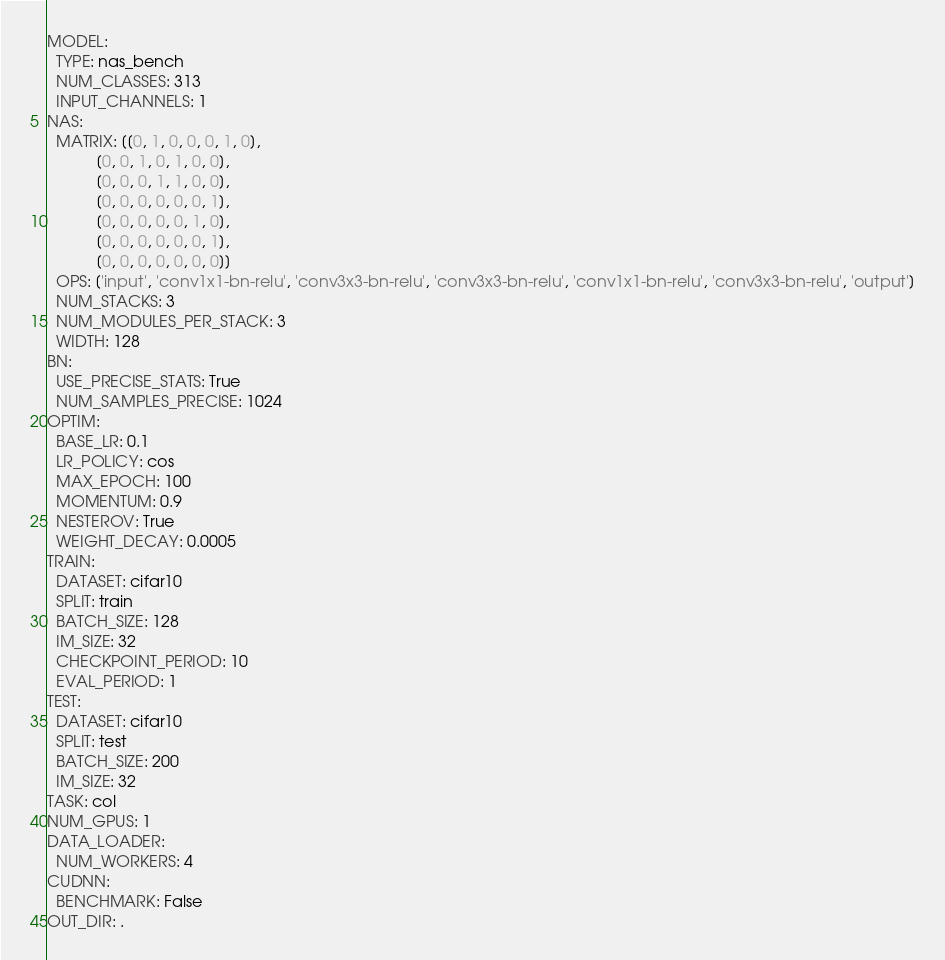Convert code to text. <code><loc_0><loc_0><loc_500><loc_500><_YAML_>MODEL:
  TYPE: nas_bench
  NUM_CLASSES: 313
  INPUT_CHANNELS: 1
NAS:
  MATRIX: [[0, 1, 0, 0, 0, 1, 0],
           [0, 0, 1, 0, 1, 0, 0],
           [0, 0, 0, 1, 1, 0, 0],
           [0, 0, 0, 0, 0, 0, 1],
           [0, 0, 0, 0, 0, 1, 0],
           [0, 0, 0, 0, 0, 0, 1],
           [0, 0, 0, 0, 0, 0, 0]]
  OPS: ['input', 'conv1x1-bn-relu', 'conv3x3-bn-relu', 'conv3x3-bn-relu', 'conv1x1-bn-relu', 'conv3x3-bn-relu', 'output']
  NUM_STACKS: 3
  NUM_MODULES_PER_STACK: 3
  WIDTH: 128
BN:
  USE_PRECISE_STATS: True
  NUM_SAMPLES_PRECISE: 1024
OPTIM:
  BASE_LR: 0.1
  LR_POLICY: cos
  MAX_EPOCH: 100
  MOMENTUM: 0.9
  NESTEROV: True
  WEIGHT_DECAY: 0.0005
TRAIN:
  DATASET: cifar10
  SPLIT: train
  BATCH_SIZE: 128
  IM_SIZE: 32
  CHECKPOINT_PERIOD: 10
  EVAL_PERIOD: 1
TEST:
  DATASET: cifar10
  SPLIT: test
  BATCH_SIZE: 200
  IM_SIZE: 32
TASK: col
NUM_GPUS: 1
DATA_LOADER:
  NUM_WORKERS: 4
CUDNN:
  BENCHMARK: False
OUT_DIR: .
</code> 